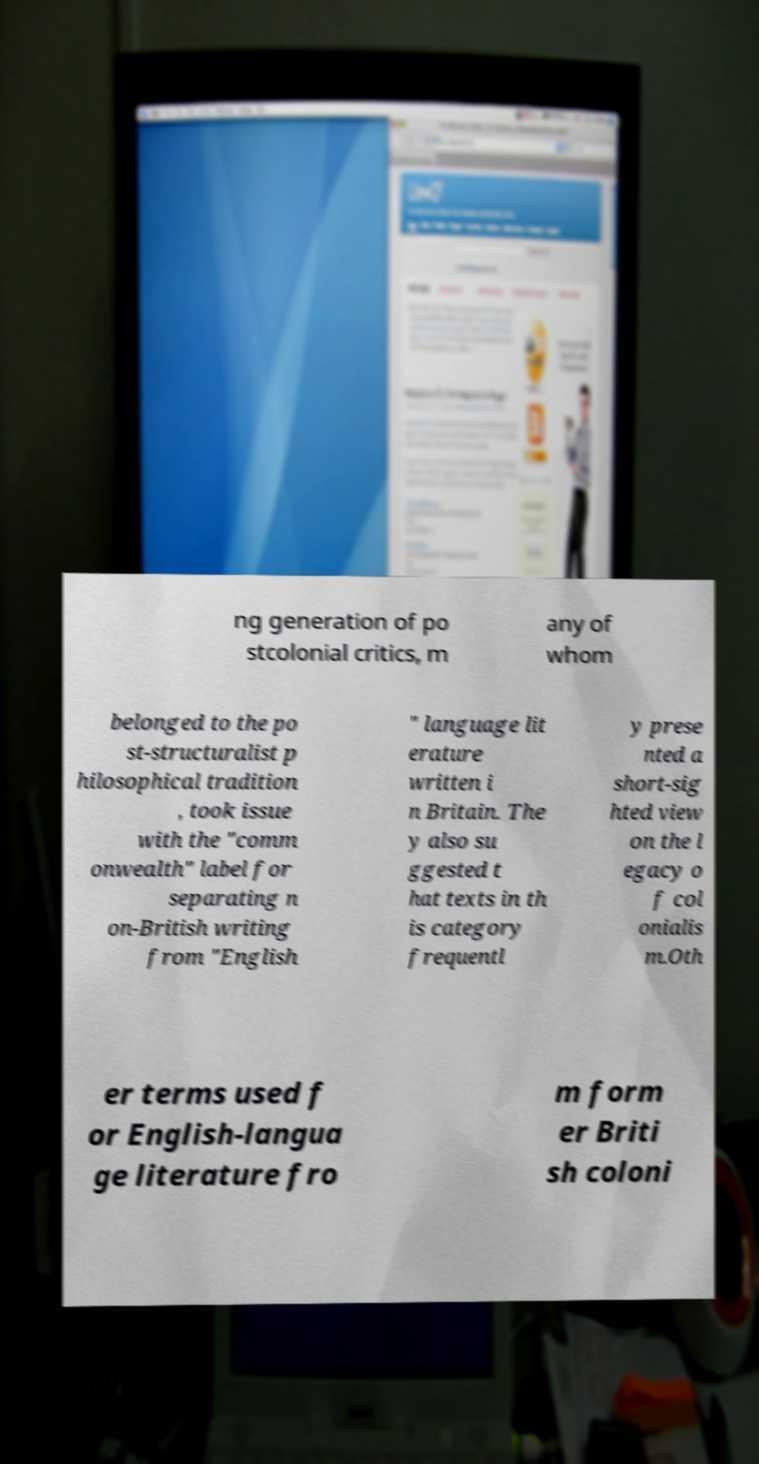Please read and relay the text visible in this image. What does it say? ng generation of po stcolonial critics, m any of whom belonged to the po st-structuralist p hilosophical tradition , took issue with the "comm onwealth" label for separating n on-British writing from "English " language lit erature written i n Britain. The y also su ggested t hat texts in th is category frequentl y prese nted a short-sig hted view on the l egacy o f col onialis m.Oth er terms used f or English-langua ge literature fro m form er Briti sh coloni 